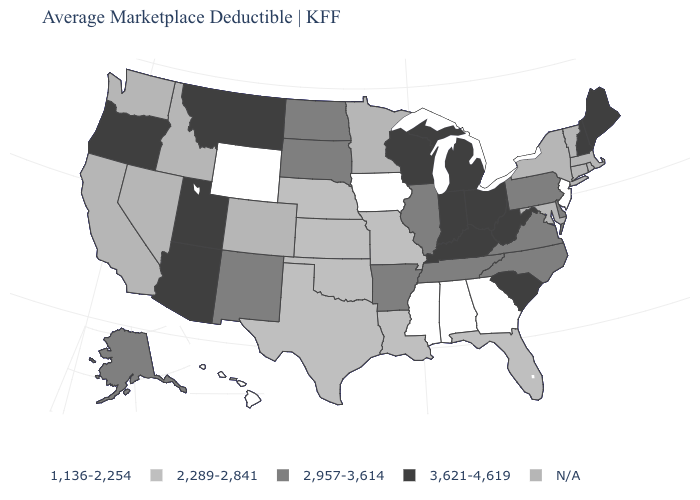What is the value of Arizona?
Answer briefly. 3,621-4,619. What is the value of Vermont?
Write a very short answer. N/A. What is the highest value in states that border New Mexico?
Answer briefly. 3,621-4,619. What is the value of West Virginia?
Quick response, please. 3,621-4,619. What is the lowest value in the USA?
Answer briefly. 1,136-2,254. Which states hav the highest value in the MidWest?
Concise answer only. Indiana, Michigan, Ohio, Wisconsin. How many symbols are there in the legend?
Be succinct. 5. Name the states that have a value in the range 2,289-2,841?
Answer briefly. Florida, Kansas, Louisiana, Missouri, Nebraska, Oklahoma, Texas. Is the legend a continuous bar?
Keep it brief. No. What is the value of Washington?
Keep it brief. N/A. Does Tennessee have the highest value in the South?
Write a very short answer. No. What is the value of North Carolina?
Short answer required. 2,957-3,614. 